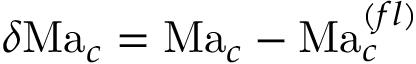Convert formula to latex. <formula><loc_0><loc_0><loc_500><loc_500>\delta M a _ { c } = M a _ { c } - M a _ { c } ^ { ( f l ) }</formula> 